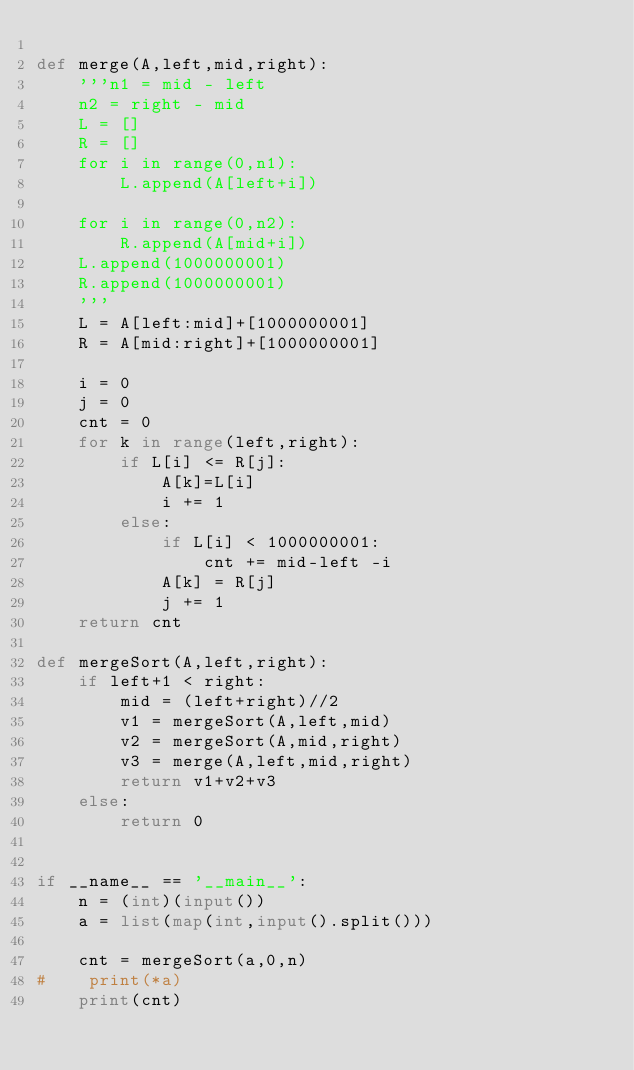<code> <loc_0><loc_0><loc_500><loc_500><_Python_>
def merge(A,left,mid,right):
    '''n1 = mid - left
    n2 = right - mid
    L = []
    R = []
    for i in range(0,n1):
        L.append(A[left+i])
 
    for i in range(0,n2):
        R.append(A[mid+i])
    L.append(1000000001)
    R.append(1000000001)
    '''
    L = A[left:mid]+[1000000001]
    R = A[mid:right]+[1000000001]
 
    i = 0
    j = 0
    cnt = 0
    for k in range(left,right):
        if L[i] <= R[j]:
            A[k]=L[i]
            i += 1
        else:
            if L[i] < 1000000001:
                cnt += mid-left -i
            A[k] = R[j]
            j += 1
    return cnt
 
def mergeSort(A,left,right):
    if left+1 < right:
        mid = (left+right)//2
        v1 = mergeSort(A,left,mid)
        v2 = mergeSort(A,mid,right)
        v3 = merge(A,left,mid,right)
        return v1+v2+v3
    else:
        return 0
 
 
if __name__ == '__main__':
    n = (int)(input())
    a = list(map(int,input().split()))
     
    cnt = mergeSort(a,0,n)
#    print(*a)
    print(cnt)</code> 